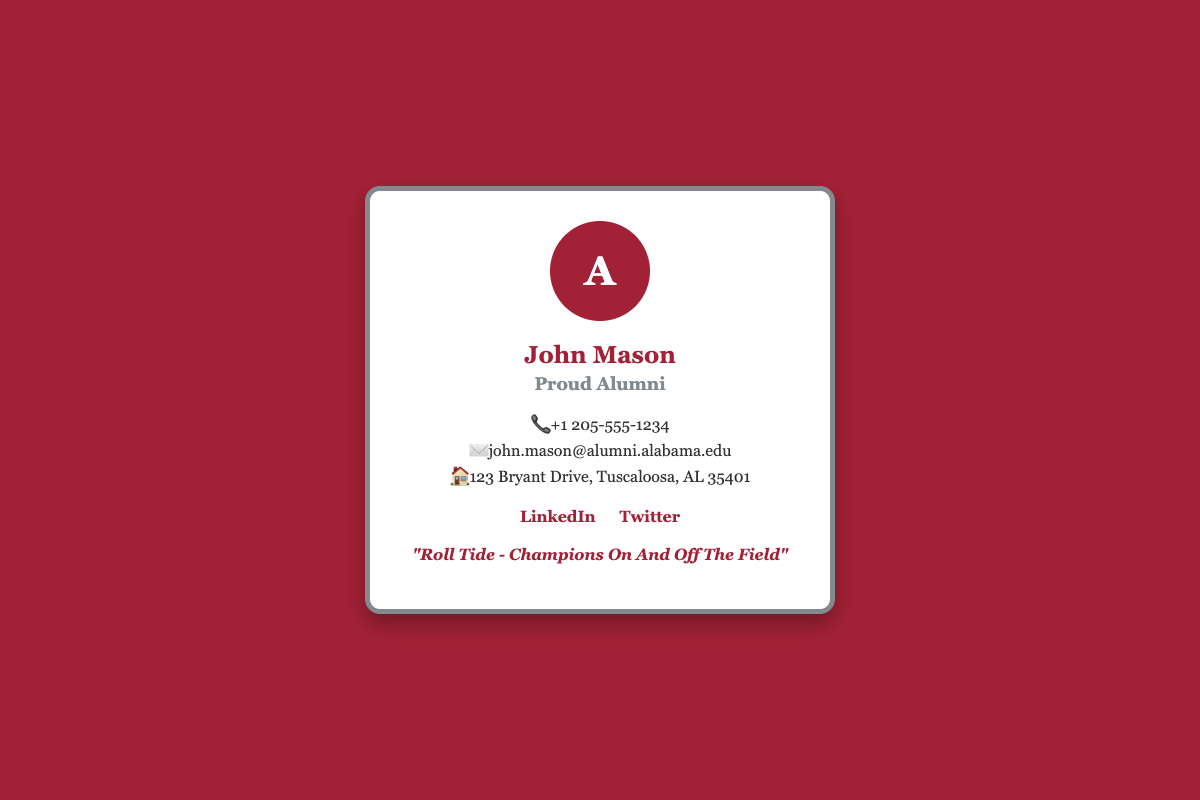what is the name on the business card? The business card features the name of the individual prominently displayed.
Answer: John Mason what is the profession listed on the card? The card indicates the individual's status as an alum with a proud title.
Answer: Proud Alumni what is the phone number provided? The document contains a specific phone number listed under contact information.
Answer: +1 205-555-1234 what is the email address shown? The card includes a professional email for alumni contact.
Answer: john.mason@alumni.alabama.edu where is the individual located? The business card provides an address, a relevant detail for location.
Answer: 123 Bryant Drive, Tuscaloosa, AL 35401 which social media platform has the LinkedIn link? The card provides links to social media accounts, including one specific platform.
Answer: LinkedIn what is the motto stated on the card? The document includes a motivational phrase that reflects pride in the team.
Answer: "Roll Tide - Champions On And Off The Field" how many social media links are provided? The card includes links to specific social media profiles.
Answer: 2 what color is the background of the business card? The background color is an important visual element in the design of the card.
Answer: Crimson 